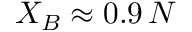Convert formula to latex. <formula><loc_0><loc_0><loc_500><loc_500>X _ { B } \approx 0 . 9 \, N</formula> 